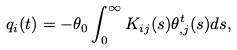<formula> <loc_0><loc_0><loc_500><loc_500>q _ { i } ( t ) = - \theta _ { 0 } \int _ { 0 } ^ { \infty } K _ { i j } ( s ) \theta _ { , j } ^ { t } ( s ) d s ,</formula> 